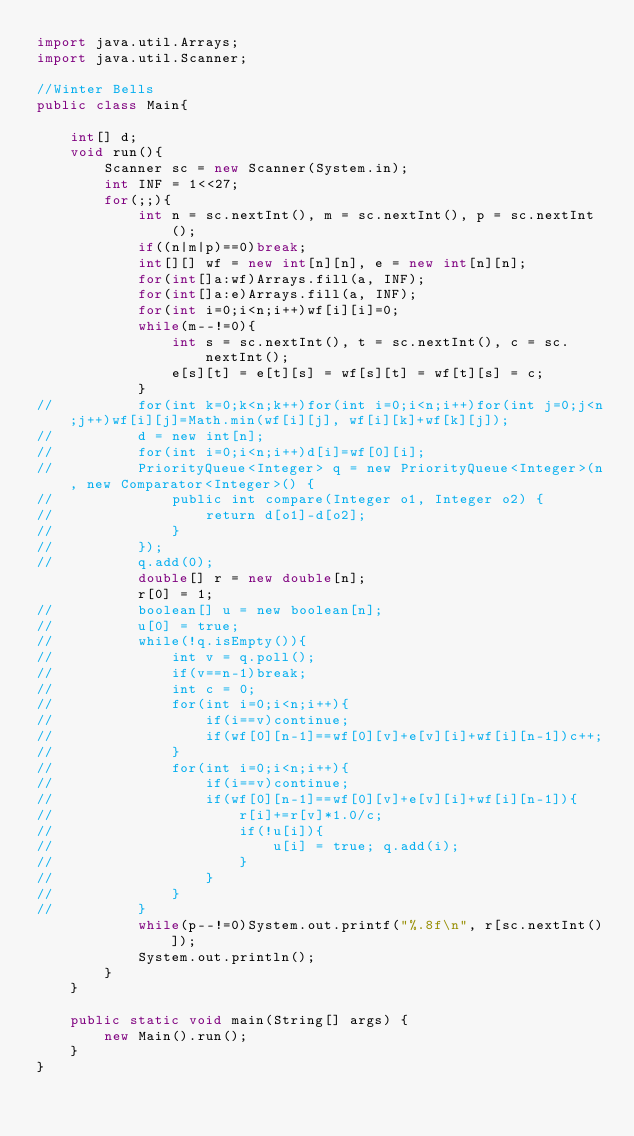Convert code to text. <code><loc_0><loc_0><loc_500><loc_500><_Java_>import java.util.Arrays;
import java.util.Scanner;

//Winter Bells
public class Main{

	int[] d;
	void run(){
		Scanner sc = new Scanner(System.in);
		int INF = 1<<27;
		for(;;){
			int n = sc.nextInt(), m = sc.nextInt(), p = sc.nextInt();
			if((n|m|p)==0)break;
			int[][] wf = new int[n][n], e = new int[n][n];
			for(int[]a:wf)Arrays.fill(a, INF);
			for(int[]a:e)Arrays.fill(a, INF);
			for(int i=0;i<n;i++)wf[i][i]=0;
			while(m--!=0){
				int s = sc.nextInt(), t = sc.nextInt(), c = sc.nextInt();
				e[s][t] = e[t][s] = wf[s][t] = wf[t][s] = c;
			}
//			for(int k=0;k<n;k++)for(int i=0;i<n;i++)for(int j=0;j<n;j++)wf[i][j]=Math.min(wf[i][j], wf[i][k]+wf[k][j]);
//			d = new int[n];
//			for(int i=0;i<n;i++)d[i]=wf[0][i];
//			PriorityQueue<Integer> q = new PriorityQueue<Integer>(n, new Comparator<Integer>() {
//				public int compare(Integer o1, Integer o2) {
//					return d[o1]-d[o2];
//				}
//			});
//			q.add(0);
			double[] r = new double[n];
			r[0] = 1;
//			boolean[] u = new boolean[n];
//			u[0] = true;
//			while(!q.isEmpty()){
//				int v = q.poll();
//				if(v==n-1)break;
//				int c = 0;
//				for(int i=0;i<n;i++){
//					if(i==v)continue;
//					if(wf[0][n-1]==wf[0][v]+e[v][i]+wf[i][n-1])c++;
//				}
//				for(int i=0;i<n;i++){
//					if(i==v)continue;
//					if(wf[0][n-1]==wf[0][v]+e[v][i]+wf[i][n-1]){
//						r[i]+=r[v]*1.0/c;
//						if(!u[i]){
//							u[i] = true; q.add(i);
//						}
//					}
//				}
//			}
			while(p--!=0)System.out.printf("%.8f\n", r[sc.nextInt()]);
			System.out.println();
		}
	}
	
	public static void main(String[] args) {
		new Main().run();
	}
}</code> 